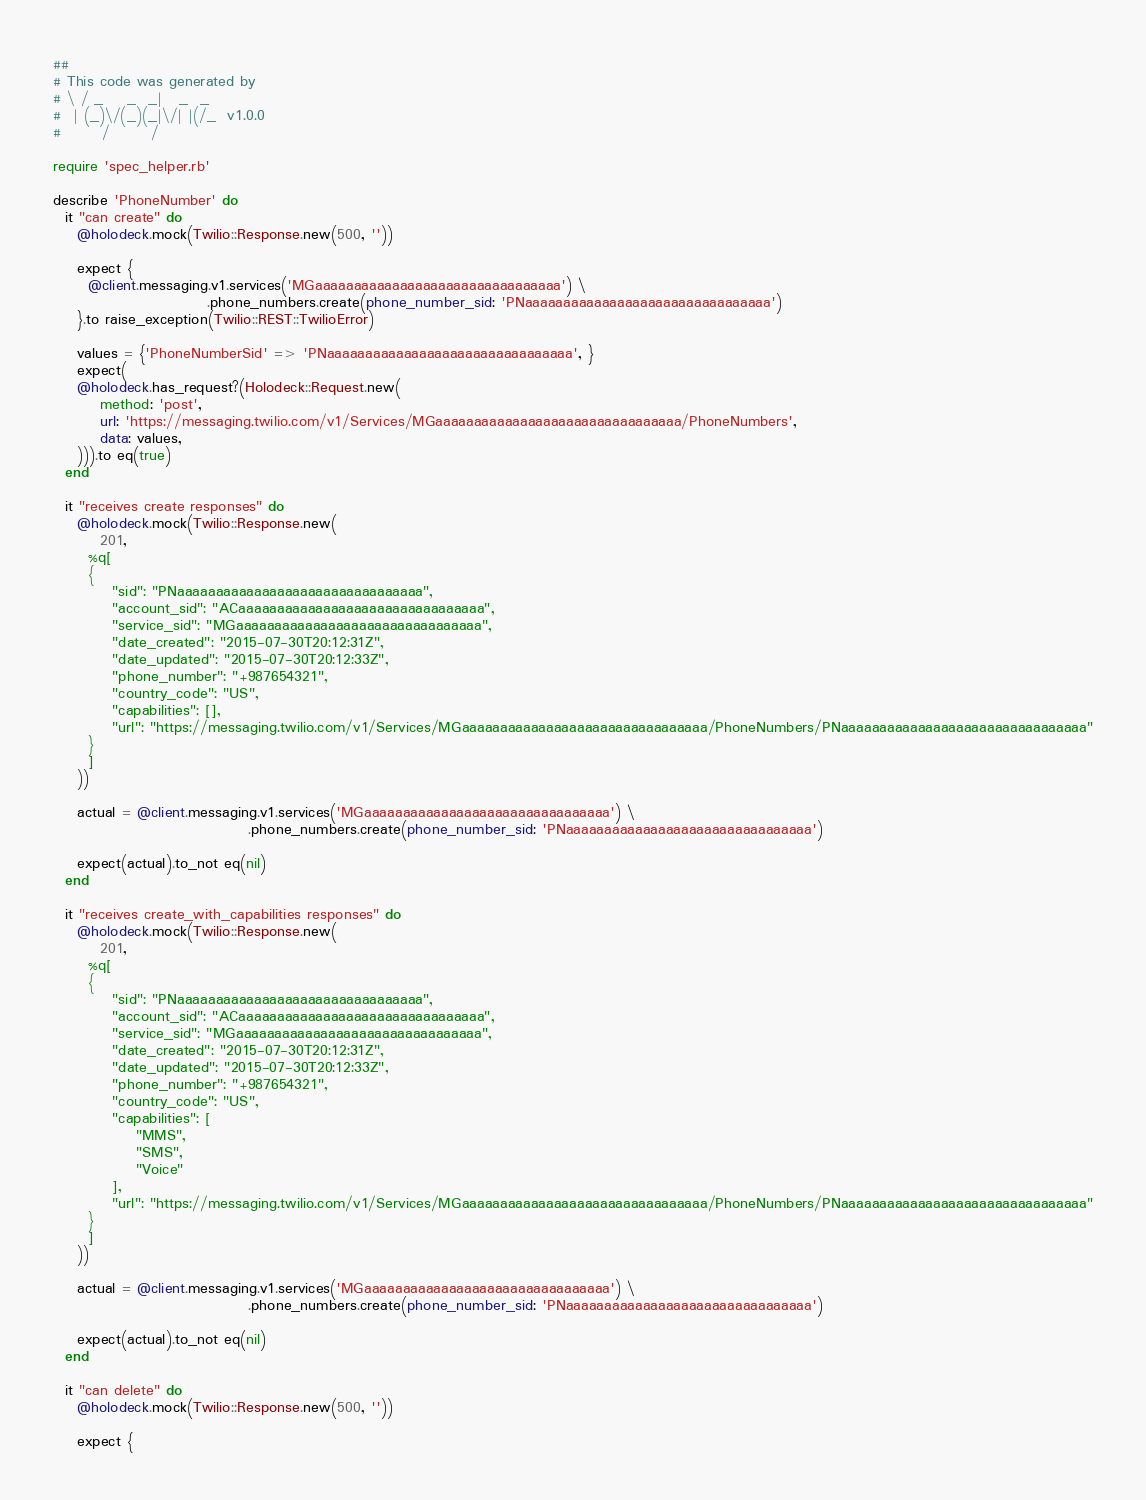Convert code to text. <code><loc_0><loc_0><loc_500><loc_500><_Ruby_>##
# This code was generated by
# \ / _    _  _|   _  _
#  | (_)\/(_)(_|\/| |(/_  v1.0.0
#       /       /

require 'spec_helper.rb'

describe 'PhoneNumber' do
  it "can create" do
    @holodeck.mock(Twilio::Response.new(500, ''))

    expect {
      @client.messaging.v1.services('MGaaaaaaaaaaaaaaaaaaaaaaaaaaaaaaaa') \
                          .phone_numbers.create(phone_number_sid: 'PNaaaaaaaaaaaaaaaaaaaaaaaaaaaaaaaa')
    }.to raise_exception(Twilio::REST::TwilioError)

    values = {'PhoneNumberSid' => 'PNaaaaaaaaaaaaaaaaaaaaaaaaaaaaaaaa', }
    expect(
    @holodeck.has_request?(Holodeck::Request.new(
        method: 'post',
        url: 'https://messaging.twilio.com/v1/Services/MGaaaaaaaaaaaaaaaaaaaaaaaaaaaaaaaa/PhoneNumbers',
        data: values,
    ))).to eq(true)
  end

  it "receives create responses" do
    @holodeck.mock(Twilio::Response.new(
        201,
      %q[
      {
          "sid": "PNaaaaaaaaaaaaaaaaaaaaaaaaaaaaaaaa",
          "account_sid": "ACaaaaaaaaaaaaaaaaaaaaaaaaaaaaaaaa",
          "service_sid": "MGaaaaaaaaaaaaaaaaaaaaaaaaaaaaaaaa",
          "date_created": "2015-07-30T20:12:31Z",
          "date_updated": "2015-07-30T20:12:33Z",
          "phone_number": "+987654321",
          "country_code": "US",
          "capabilities": [],
          "url": "https://messaging.twilio.com/v1/Services/MGaaaaaaaaaaaaaaaaaaaaaaaaaaaaaaaa/PhoneNumbers/PNaaaaaaaaaaaaaaaaaaaaaaaaaaaaaaaa"
      }
      ]
    ))

    actual = @client.messaging.v1.services('MGaaaaaaaaaaaaaaaaaaaaaaaaaaaaaaaa') \
                                 .phone_numbers.create(phone_number_sid: 'PNaaaaaaaaaaaaaaaaaaaaaaaaaaaaaaaa')

    expect(actual).to_not eq(nil)
  end

  it "receives create_with_capabilities responses" do
    @holodeck.mock(Twilio::Response.new(
        201,
      %q[
      {
          "sid": "PNaaaaaaaaaaaaaaaaaaaaaaaaaaaaaaaa",
          "account_sid": "ACaaaaaaaaaaaaaaaaaaaaaaaaaaaaaaaa",
          "service_sid": "MGaaaaaaaaaaaaaaaaaaaaaaaaaaaaaaaa",
          "date_created": "2015-07-30T20:12:31Z",
          "date_updated": "2015-07-30T20:12:33Z",
          "phone_number": "+987654321",
          "country_code": "US",
          "capabilities": [
              "MMS",
              "SMS",
              "Voice"
          ],
          "url": "https://messaging.twilio.com/v1/Services/MGaaaaaaaaaaaaaaaaaaaaaaaaaaaaaaaa/PhoneNumbers/PNaaaaaaaaaaaaaaaaaaaaaaaaaaaaaaaa"
      }
      ]
    ))

    actual = @client.messaging.v1.services('MGaaaaaaaaaaaaaaaaaaaaaaaaaaaaaaaa') \
                                 .phone_numbers.create(phone_number_sid: 'PNaaaaaaaaaaaaaaaaaaaaaaaaaaaaaaaa')

    expect(actual).to_not eq(nil)
  end

  it "can delete" do
    @holodeck.mock(Twilio::Response.new(500, ''))

    expect {</code> 